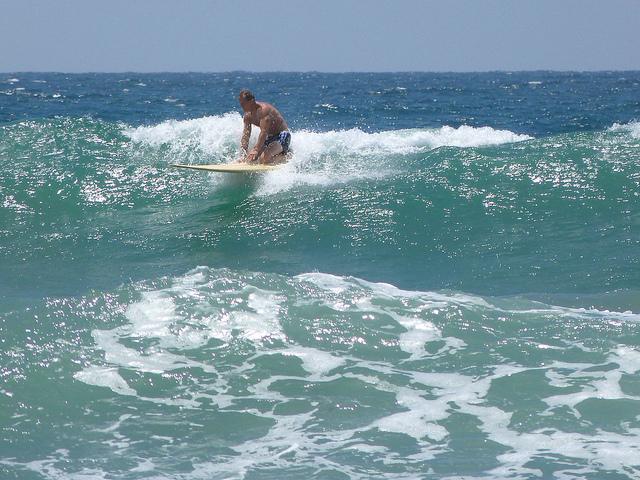How many people are there?
Give a very brief answer. 1. How many skis are on the ground?
Give a very brief answer. 0. 